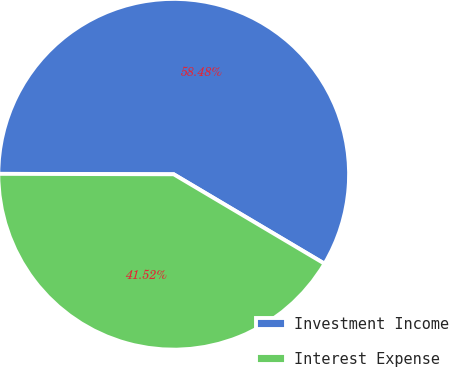Convert chart to OTSL. <chart><loc_0><loc_0><loc_500><loc_500><pie_chart><fcel>Investment Income<fcel>Interest Expense<nl><fcel>58.48%<fcel>41.52%<nl></chart> 